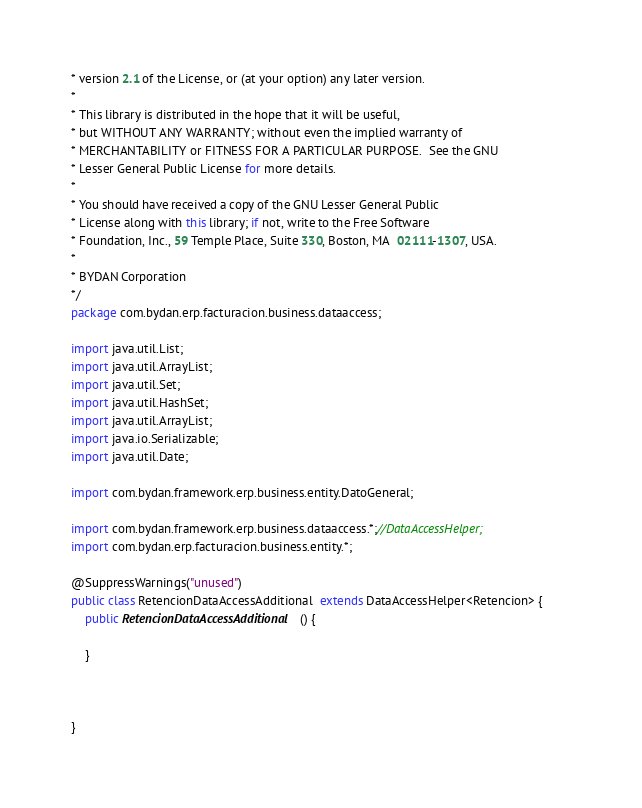<code> <loc_0><loc_0><loc_500><loc_500><_Java_>* version 2.1 of the License, or (at your option) any later version.
* 
* This library is distributed in the hope that it will be useful,
* but WITHOUT ANY WARRANTY; without even the implied warranty of
* MERCHANTABILITY or FITNESS FOR A PARTICULAR PURPOSE.  See the GNU
* Lesser General Public License for more details.
* 
* You should have received a copy of the GNU Lesser General Public
* License along with this library; if not, write to the Free Software
* Foundation, Inc., 59 Temple Place, Suite 330, Boston, MA  02111-1307, USA.
* 
* BYDAN Corporation
*/
package com.bydan.erp.facturacion.business.dataaccess;

import java.util.List;
import java.util.ArrayList;
import java.util.Set;
import java.util.HashSet;
import java.util.ArrayList;
import java.io.Serializable;
import java.util.Date;

import com.bydan.framework.erp.business.entity.DatoGeneral;

import com.bydan.framework.erp.business.dataaccess.*;//DataAccessHelper;
import com.bydan.erp.facturacion.business.entity.*;

@SuppressWarnings("unused")
public class RetencionDataAccessAdditional  extends DataAccessHelper<Retencion> {		
	public RetencionDataAccessAdditional () {
		
    } 
	
	
	
}</code> 